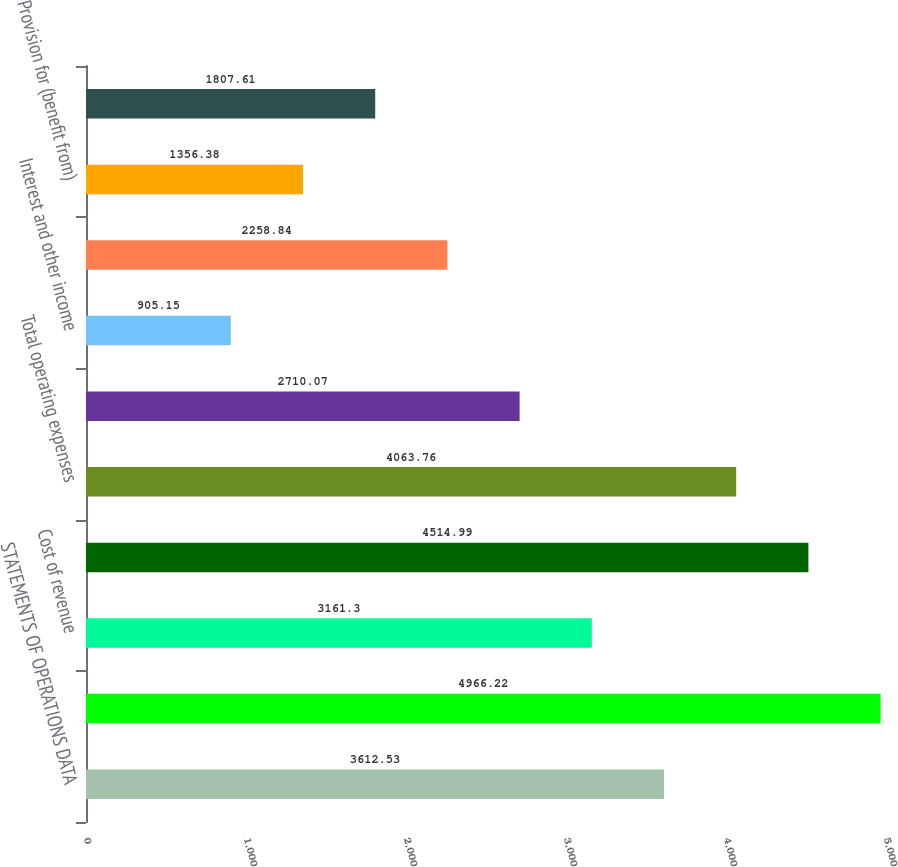Convert chart. <chart><loc_0><loc_0><loc_500><loc_500><bar_chart><fcel>STATEMENTS OF OPERATIONS DATA<fcel>Net revenue<fcel>Cost of revenue<fcel>Gross profit<fcel>Total operating expenses<fcel>Operating income<fcel>Interest and other income<fcel>Income before provision for<fcel>Provision for (benefit from)<fcel>Net income<nl><fcel>3612.53<fcel>4966.22<fcel>3161.3<fcel>4514.99<fcel>4063.76<fcel>2710.07<fcel>905.15<fcel>2258.84<fcel>1356.38<fcel>1807.61<nl></chart> 